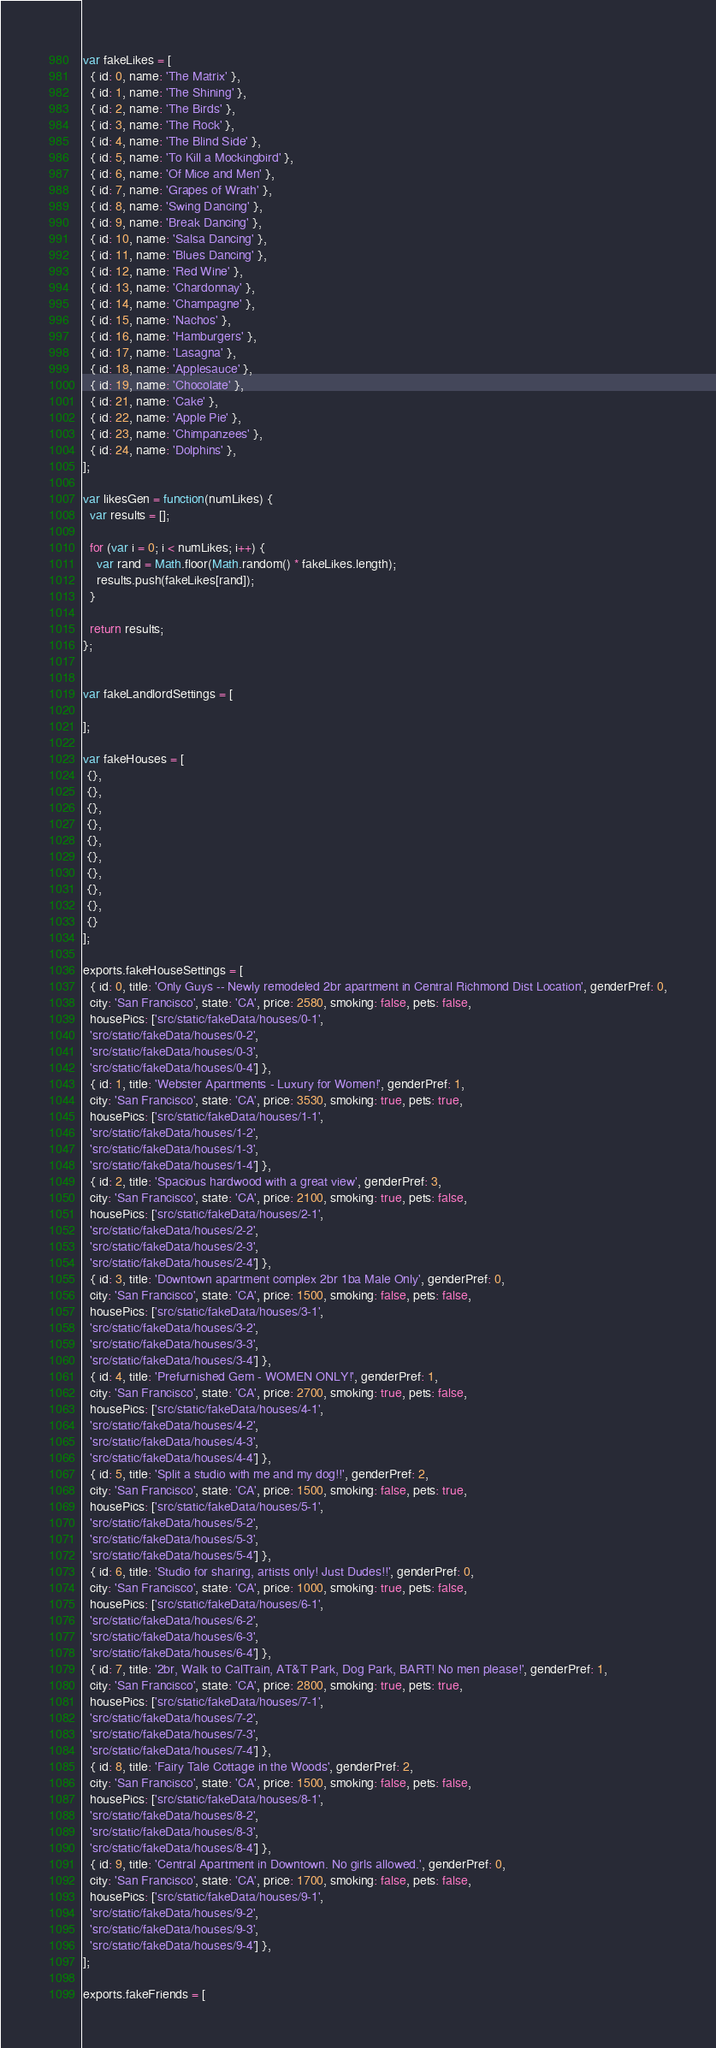<code> <loc_0><loc_0><loc_500><loc_500><_JavaScript_>var fakeLikes = [
  { id: 0, name: 'The Matrix' },
  { id: 1, name: 'The Shining' },
  { id: 2, name: 'The Birds' },
  { id: 3, name: 'The Rock' },
  { id: 4, name: 'The Blind Side' },
  { id: 5, name: 'To Kill a Mockingbird' },
  { id: 6, name: 'Of Mice and Men' },
  { id: 7, name: 'Grapes of Wrath' },
  { id: 8, name: 'Swing Dancing' },
  { id: 9, name: 'Break Dancing' },
  { id: 10, name: 'Salsa Dancing' },
  { id: 11, name: 'Blues Dancing' },
  { id: 12, name: 'Red Wine' },
  { id: 13, name: 'Chardonnay' },
  { id: 14, name: 'Champagne' },
  { id: 15, name: 'Nachos' },
  { id: 16, name: 'Hamburgers' },
  { id: 17, name: 'Lasagna' },
  { id: 18, name: 'Applesauce' },
  { id: 19, name: 'Chocolate' },
  { id: 21, name: 'Cake' },
  { id: 22, name: 'Apple Pie' },
  { id: 23, name: 'Chimpanzees' },
  { id: 24, name: 'Dolphins' },
];

var likesGen = function(numLikes) {
  var results = [];

  for (var i = 0; i < numLikes; i++) {
    var rand = Math.floor(Math.random() * fakeLikes.length);
    results.push(fakeLikes[rand]);
  }

  return results;
};


var fakeLandlordSettings = [

];

var fakeHouses = [
 {},
 {},
 {},
 {},
 {},
 {},
 {},
 {},
 {},
 {}
];

exports.fakeHouseSettings = [
  { id: 0, title: 'Only Guys -- Newly remodeled 2br apartment in Central Richmond Dist Location', genderPref: 0,
  city: 'San Francisco', state: 'CA', price: 2580, smoking: false, pets: false,
  housePics: ['src/static/fakeData/houses/0-1',
  'src/static/fakeData/houses/0-2',
  'src/static/fakeData/houses/0-3',
  'src/static/fakeData/houses/0-4'] },
  { id: 1, title: 'Webster Apartments - Luxury for Women!', genderPref: 1,
  city: 'San Francisco', state: 'CA', price: 3530, smoking: true, pets: true,
  housePics: ['src/static/fakeData/houses/1-1',
  'src/static/fakeData/houses/1-2',
  'src/static/fakeData/houses/1-3',
  'src/static/fakeData/houses/1-4'] },
  { id: 2, title: 'Spacious hardwood with a great view', genderPref: 3,
  city: 'San Francisco', state: 'CA', price: 2100, smoking: true, pets: false,
  housePics: ['src/static/fakeData/houses/2-1',
  'src/static/fakeData/houses/2-2',
  'src/static/fakeData/houses/2-3',
  'src/static/fakeData/houses/2-4'] },
  { id: 3, title: 'Downtown apartment complex 2br 1ba Male Only', genderPref: 0,
  city: 'San Francisco', state: 'CA', price: 1500, smoking: false, pets: false,
  housePics: ['src/static/fakeData/houses/3-1',
  'src/static/fakeData/houses/3-2',
  'src/static/fakeData/houses/3-3',
  'src/static/fakeData/houses/3-4'] },
  { id: 4, title: 'Prefurnished Gem - WOMEN ONLY!', genderPref: 1,
  city: 'San Francisco', state: 'CA', price: 2700, smoking: true, pets: false,
  housePics: ['src/static/fakeData/houses/4-1',
  'src/static/fakeData/houses/4-2',
  'src/static/fakeData/houses/4-3',
  'src/static/fakeData/houses/4-4'] },
  { id: 5, title: 'Split a studio with me and my dog!!', genderPref: 2,
  city: 'San Francisco', state: 'CA', price: 1500, smoking: false, pets: true,
  housePics: ['src/static/fakeData/houses/5-1',
  'src/static/fakeData/houses/5-2',
  'src/static/fakeData/houses/5-3',
  'src/static/fakeData/houses/5-4'] },
  { id: 6, title: 'Studio for sharing, artists only! Just Dudes!!', genderPref: 0,
  city: 'San Francisco', state: 'CA', price: 1000, smoking: true, pets: false,
  housePics: ['src/static/fakeData/houses/6-1',
  'src/static/fakeData/houses/6-2',
  'src/static/fakeData/houses/6-3',
  'src/static/fakeData/houses/6-4'] },
  { id: 7, title: '2br, Walk to CalTrain, AT&T Park, Dog Park, BART! No men please!', genderPref: 1,
  city: 'San Francisco', state: 'CA', price: 2800, smoking: true, pets: true,
  housePics: ['src/static/fakeData/houses/7-1',
  'src/static/fakeData/houses/7-2',
  'src/static/fakeData/houses/7-3',
  'src/static/fakeData/houses/7-4'] },
  { id: 8, title: 'Fairy Tale Cottage in the Woods', genderPref: 2,
  city: 'San Francisco', state: 'CA', price: 1500, smoking: false, pets: false,
  housePics: ['src/static/fakeData/houses/8-1',
  'src/static/fakeData/houses/8-2',
  'src/static/fakeData/houses/8-3',
  'src/static/fakeData/houses/8-4'] },
  { id: 9, title: 'Central Apartment in Downtown. No girls allowed.', genderPref: 0,
  city: 'San Francisco', state: 'CA', price: 1700, smoking: false, pets: false,
  housePics: ['src/static/fakeData/houses/9-1',
  'src/static/fakeData/houses/9-2',
  'src/static/fakeData/houses/9-3',
  'src/static/fakeData/houses/9-4'] },
];

exports.fakeFriends = [</code> 